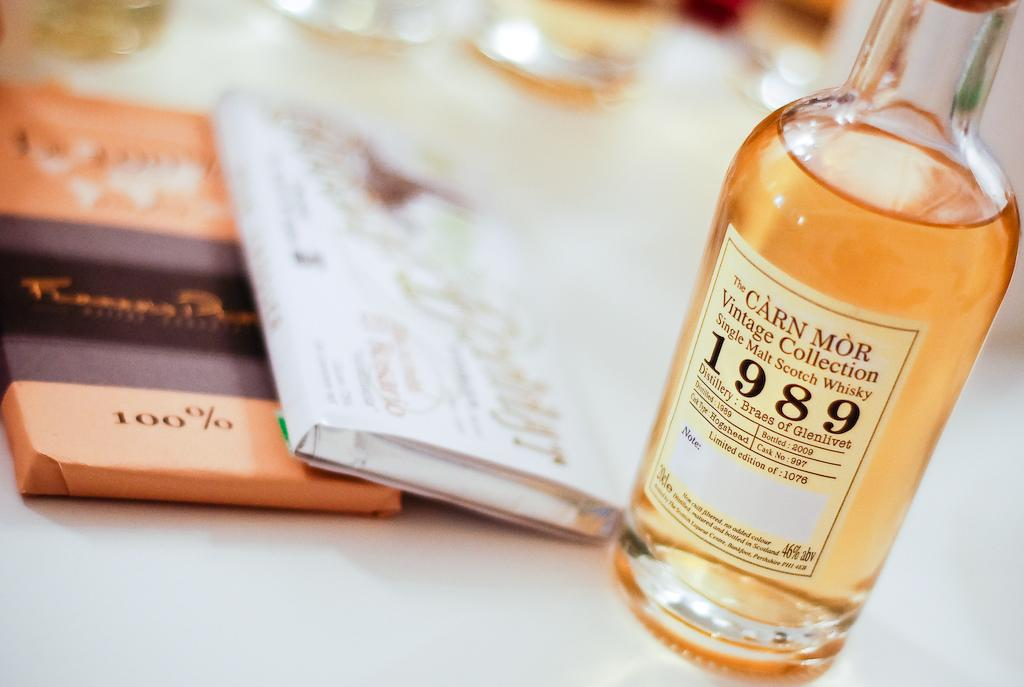<image>
Summarize the visual content of the image. A Vintage Collection bottle of Scotch Whisky 1989 sits on a table. 